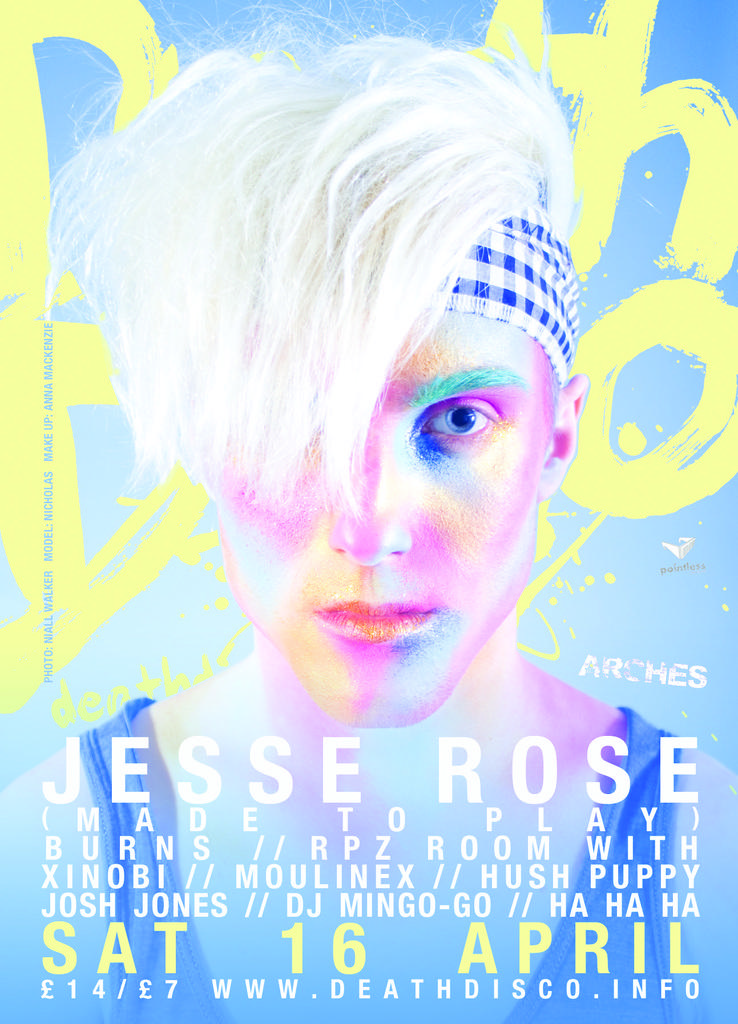What is present in the image that features an image of a person? There is a poster in the image that contains an image of a person. What else can be found on the poster besides the image? There is text written on the poster. What type of bread can be seen in the image? There is no bread present in the image; it features a poster with an image of a person and text. 